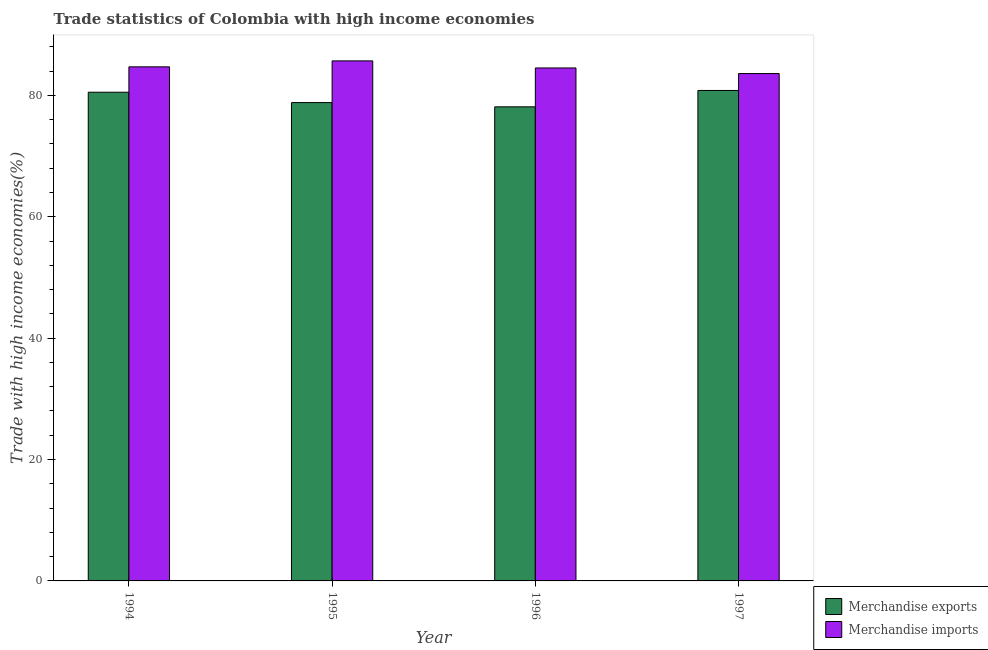How many groups of bars are there?
Offer a very short reply. 4. Are the number of bars on each tick of the X-axis equal?
Your answer should be very brief. Yes. How many bars are there on the 3rd tick from the left?
Give a very brief answer. 2. How many bars are there on the 4th tick from the right?
Give a very brief answer. 2. What is the label of the 1st group of bars from the left?
Ensure brevity in your answer.  1994. What is the merchandise imports in 1997?
Your answer should be very brief. 83.6. Across all years, what is the maximum merchandise imports?
Provide a succinct answer. 85.69. Across all years, what is the minimum merchandise imports?
Your response must be concise. 83.6. In which year was the merchandise imports maximum?
Give a very brief answer. 1995. In which year was the merchandise imports minimum?
Ensure brevity in your answer.  1997. What is the total merchandise imports in the graph?
Your answer should be very brief. 338.53. What is the difference between the merchandise imports in 1994 and that in 1996?
Provide a succinct answer. 0.18. What is the difference between the merchandise imports in 1997 and the merchandise exports in 1994?
Give a very brief answer. -1.11. What is the average merchandise exports per year?
Your response must be concise. 79.57. In how many years, is the merchandise imports greater than 32 %?
Give a very brief answer. 4. What is the ratio of the merchandise imports in 1995 to that in 1996?
Your answer should be compact. 1.01. What is the difference between the highest and the second highest merchandise exports?
Give a very brief answer. 0.29. What is the difference between the highest and the lowest merchandise exports?
Keep it short and to the point. 2.7. In how many years, is the merchandise exports greater than the average merchandise exports taken over all years?
Provide a short and direct response. 2. What does the 1st bar from the left in 1996 represents?
Provide a short and direct response. Merchandise exports. How many bars are there?
Keep it short and to the point. 8. How many years are there in the graph?
Make the answer very short. 4. What is the difference between two consecutive major ticks on the Y-axis?
Keep it short and to the point. 20. Does the graph contain grids?
Keep it short and to the point. No. How many legend labels are there?
Offer a terse response. 2. What is the title of the graph?
Provide a short and direct response. Trade statistics of Colombia with high income economies. Does "Fertility rate" appear as one of the legend labels in the graph?
Keep it short and to the point. No. What is the label or title of the Y-axis?
Your answer should be very brief. Trade with high income economies(%). What is the Trade with high income economies(%) in Merchandise exports in 1994?
Provide a succinct answer. 80.53. What is the Trade with high income economies(%) in Merchandise imports in 1994?
Offer a terse response. 84.71. What is the Trade with high income economies(%) of Merchandise exports in 1995?
Provide a short and direct response. 78.82. What is the Trade with high income economies(%) of Merchandise imports in 1995?
Offer a very short reply. 85.69. What is the Trade with high income economies(%) in Merchandise exports in 1996?
Make the answer very short. 78.12. What is the Trade with high income economies(%) in Merchandise imports in 1996?
Make the answer very short. 84.52. What is the Trade with high income economies(%) in Merchandise exports in 1997?
Your answer should be very brief. 80.82. What is the Trade with high income economies(%) of Merchandise imports in 1997?
Your answer should be compact. 83.6. Across all years, what is the maximum Trade with high income economies(%) in Merchandise exports?
Offer a terse response. 80.82. Across all years, what is the maximum Trade with high income economies(%) in Merchandise imports?
Your answer should be compact. 85.69. Across all years, what is the minimum Trade with high income economies(%) of Merchandise exports?
Your response must be concise. 78.12. Across all years, what is the minimum Trade with high income economies(%) in Merchandise imports?
Your answer should be compact. 83.6. What is the total Trade with high income economies(%) in Merchandise exports in the graph?
Your response must be concise. 318.28. What is the total Trade with high income economies(%) in Merchandise imports in the graph?
Your answer should be compact. 338.53. What is the difference between the Trade with high income economies(%) of Merchandise exports in 1994 and that in 1995?
Ensure brevity in your answer.  1.71. What is the difference between the Trade with high income economies(%) in Merchandise imports in 1994 and that in 1995?
Provide a succinct answer. -0.98. What is the difference between the Trade with high income economies(%) in Merchandise exports in 1994 and that in 1996?
Your answer should be compact. 2.41. What is the difference between the Trade with high income economies(%) in Merchandise imports in 1994 and that in 1996?
Keep it short and to the point. 0.18. What is the difference between the Trade with high income economies(%) in Merchandise exports in 1994 and that in 1997?
Your response must be concise. -0.29. What is the difference between the Trade with high income economies(%) in Merchandise imports in 1994 and that in 1997?
Provide a short and direct response. 1.11. What is the difference between the Trade with high income economies(%) in Merchandise exports in 1995 and that in 1996?
Give a very brief answer. 0.7. What is the difference between the Trade with high income economies(%) in Merchandise imports in 1995 and that in 1996?
Ensure brevity in your answer.  1.17. What is the difference between the Trade with high income economies(%) in Merchandise exports in 1995 and that in 1997?
Your answer should be compact. -2. What is the difference between the Trade with high income economies(%) in Merchandise imports in 1995 and that in 1997?
Your response must be concise. 2.09. What is the difference between the Trade with high income economies(%) of Merchandise exports in 1996 and that in 1997?
Your answer should be very brief. -2.7. What is the difference between the Trade with high income economies(%) of Merchandise imports in 1996 and that in 1997?
Your answer should be compact. 0.92. What is the difference between the Trade with high income economies(%) in Merchandise exports in 1994 and the Trade with high income economies(%) in Merchandise imports in 1995?
Your answer should be very brief. -5.16. What is the difference between the Trade with high income economies(%) of Merchandise exports in 1994 and the Trade with high income economies(%) of Merchandise imports in 1996?
Offer a terse response. -4. What is the difference between the Trade with high income economies(%) in Merchandise exports in 1994 and the Trade with high income economies(%) in Merchandise imports in 1997?
Offer a very short reply. -3.08. What is the difference between the Trade with high income economies(%) of Merchandise exports in 1995 and the Trade with high income economies(%) of Merchandise imports in 1996?
Give a very brief answer. -5.71. What is the difference between the Trade with high income economies(%) in Merchandise exports in 1995 and the Trade with high income economies(%) in Merchandise imports in 1997?
Provide a succinct answer. -4.78. What is the difference between the Trade with high income economies(%) of Merchandise exports in 1996 and the Trade with high income economies(%) of Merchandise imports in 1997?
Your response must be concise. -5.48. What is the average Trade with high income economies(%) in Merchandise exports per year?
Offer a terse response. 79.57. What is the average Trade with high income economies(%) in Merchandise imports per year?
Your answer should be compact. 84.63. In the year 1994, what is the difference between the Trade with high income economies(%) in Merchandise exports and Trade with high income economies(%) in Merchandise imports?
Keep it short and to the point. -4.18. In the year 1995, what is the difference between the Trade with high income economies(%) of Merchandise exports and Trade with high income economies(%) of Merchandise imports?
Ensure brevity in your answer.  -6.87. In the year 1996, what is the difference between the Trade with high income economies(%) of Merchandise exports and Trade with high income economies(%) of Merchandise imports?
Keep it short and to the point. -6.41. In the year 1997, what is the difference between the Trade with high income economies(%) in Merchandise exports and Trade with high income economies(%) in Merchandise imports?
Provide a succinct answer. -2.79. What is the ratio of the Trade with high income economies(%) of Merchandise exports in 1994 to that in 1995?
Offer a very short reply. 1.02. What is the ratio of the Trade with high income economies(%) in Merchandise exports in 1994 to that in 1996?
Your answer should be compact. 1.03. What is the ratio of the Trade with high income economies(%) in Merchandise imports in 1994 to that in 1996?
Your answer should be compact. 1. What is the ratio of the Trade with high income economies(%) in Merchandise exports in 1994 to that in 1997?
Your response must be concise. 1. What is the ratio of the Trade with high income economies(%) in Merchandise imports in 1994 to that in 1997?
Keep it short and to the point. 1.01. What is the ratio of the Trade with high income economies(%) of Merchandise imports in 1995 to that in 1996?
Offer a terse response. 1.01. What is the ratio of the Trade with high income economies(%) in Merchandise exports in 1995 to that in 1997?
Your response must be concise. 0.98. What is the ratio of the Trade with high income economies(%) in Merchandise exports in 1996 to that in 1997?
Keep it short and to the point. 0.97. What is the difference between the highest and the second highest Trade with high income economies(%) of Merchandise exports?
Keep it short and to the point. 0.29. What is the difference between the highest and the second highest Trade with high income economies(%) of Merchandise imports?
Your response must be concise. 0.98. What is the difference between the highest and the lowest Trade with high income economies(%) of Merchandise exports?
Provide a succinct answer. 2.7. What is the difference between the highest and the lowest Trade with high income economies(%) in Merchandise imports?
Keep it short and to the point. 2.09. 